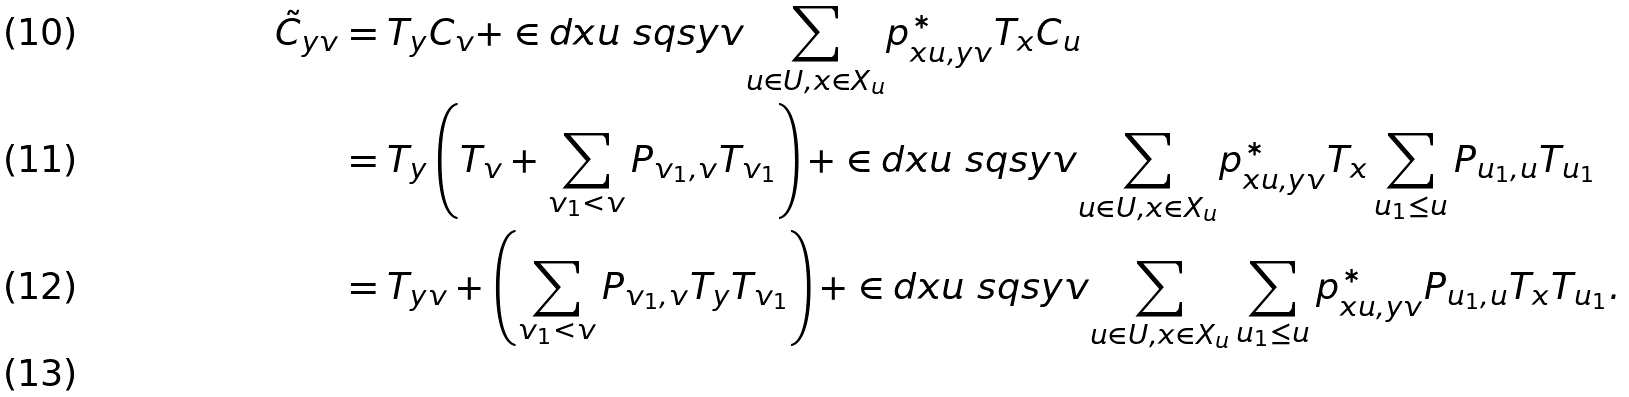<formula> <loc_0><loc_0><loc_500><loc_500>\tilde { C } _ { y v } & = T _ { y } C _ { v } + \in d { x u \ s q s y v } { \sum _ { u \in U , x \in X _ { u } } } p ^ { * } _ { x u , y v } T _ { x } C _ { u } \\ & = T _ { y } \left ( T _ { v } + \sum _ { v _ { 1 } < v } P _ { v _ { 1 } , v } T _ { v _ { 1 } } \right ) + \in d { x u \ s q s y v } { \sum _ { u \in U , x \in X _ { u } } } p ^ { * } _ { x u , y v } T _ { x } \sum _ { u _ { 1 } \leq u } P _ { u _ { 1 } , u } T _ { u _ { 1 } } \\ & = T _ { y v } + \left ( \sum _ { v _ { 1 } < v } P _ { v _ { 1 } , v } T _ { y } T _ { v _ { 1 } } \right ) + \in d { x u \ s q s y v } { \sum _ { u \in U , x \in X _ { u } } } \sum _ { u _ { 1 } \leq u } p ^ { * } _ { x u , y v } P _ { u _ { 1 } , u } T _ { x } T _ { u _ { 1 } } . \\</formula> 